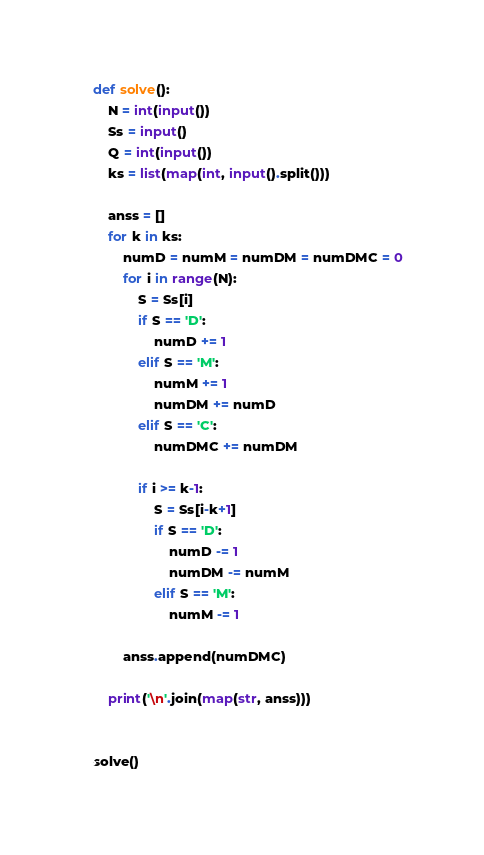<code> <loc_0><loc_0><loc_500><loc_500><_Python_>def solve():
    N = int(input())
    Ss = input()
    Q = int(input())
    ks = list(map(int, input().split()))

    anss = []
    for k in ks:
        numD = numM = numDM = numDMC = 0
        for i in range(N):
            S = Ss[i]
            if S == 'D':
                numD += 1
            elif S == 'M':
                numM += 1
                numDM += numD
            elif S == 'C':
                numDMC += numDM

            if i >= k-1:
                S = Ss[i-k+1]
                if S == 'D':
                    numD -= 1
                    numDM -= numM
                elif S == 'M':
                    numM -= 1

        anss.append(numDMC)

    print('\n'.join(map(str, anss)))


solve()
</code> 